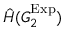Convert formula to latex. <formula><loc_0><loc_0><loc_500><loc_500>\hat { H } ( G _ { 2 } ^ { E x p } )</formula> 